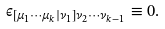Convert formula to latex. <formula><loc_0><loc_0><loc_500><loc_500>\epsilon _ { \left [ \mu _ { 1 } \cdots \mu _ { k } | \nu _ { 1 } \right ] \nu _ { 2 } \cdots \nu _ { k - 1 } } \equiv 0 .</formula> 